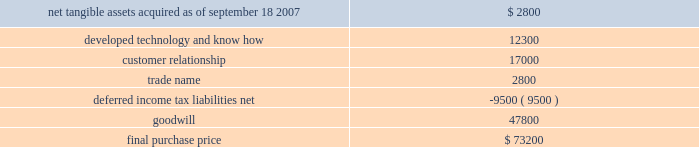Table of contents hologic , inc .
Notes to consolidated financial statements ( continued ) ( in thousands , except per share data ) the acquisition also provides for up to two annual earn-out payments not to exceed $ 15000 in the aggregate based on biolucent 2019s achievement of certain revenue targets .
The company considered the provision of eitf 95-8 , and concluded that this contingent consideration represents additional purchase price .
As a result , goodwill will be increased by the amount of the additional consideration , if any , as it is earned .
As of september 26 , 2009 , the company has not recorded any amounts for these potential earn-outs .
The allocation of the purchase price was based upon estimates of the fair value of assets acquired and liabilities assumed as of september 18 , 2007 .
The components and allocation of the purchase price consisted of the following approximate amounts: .
As part of the purchase price allocation , all intangible assets that were a part of the acquisition were identified and valued .
It was determined that only customer relationship , trade name and developed technology had separately identifiable values .
The fair value of these intangible assets was determined through the application of the income approach .
Customer relationship represented a large customer base that was expected to purchase the disposable mammopad product on a regular basis .
Trade name represented the biolucent product name that the company intended to continue to use .
Developed technology represented currently marketable purchased products that the company continues to sell as well as utilize to enhance and incorporate into the company 2019s existing products .
The deferred income tax liability relates to the tax effect of acquired identifiable intangible assets and fair value adjustments to acquired inventory , as such amounts are not deductible for tax purposes , partially offset by acquired net operating loss carryforwards of approximately $ 2400 .
Sale of gestiva on january 16 , 2008 , the company entered into a definitive agreement pursuant to which it agreed to sell full u.s .
And world-wide rights to gestiva to k-v pharmaceutical company upon approval of the pending gestiva new drug application ( the 201cgestiva nda 201d ) by the fda for a purchase price of $ 82000 .
The company received $ 9500 of the purchase price in fiscal 2008 , and the balance is due upon final approval of the gestiva nda by the fda on or before february 19 , 2010 and the production of a quantity of gestiva suitable to enable the commercial launch of the product .
Either party has the right to terminate the agreement if fda approval is not obtained by february 19 , 2010 .
The company agreed to continue its efforts to obtain fda approval of the nda for gestiva as part of this arrangement .
All costs incurred in these efforts will be reimbursed by k-v pharmaceutical and are being recorded as a credit against research and development expenses .
During fiscal 2009 and 2008 , these reimbursed costs were not material .
The company recorded the $ 9500 as a deferred gain within current liabilities in the consolidated balance sheet .
The company expects that the gain will be recognized upon the closing of the transaction following final fda approval of the gestiva nda or if the agreement is terminated .
The company cannot assure that it will be able to obtain the requisite fda approval , that the transaction will be completed or that it will receive the balance of the purchase price .
Moreover , if k-v pharmaceutical terminates the agreement as a result of a breach by the company of a material representation , warranty , covenant or agreement , the company will be required to return the funds previously received as well as expenses reimbursed by k-v .
Source : hologic inc , 10-k , november 24 , 2009 powered by morningstar ae document research 2120 the information contained herein may not be copied , adapted or distributed and is not warranted to be accurate , complete or timely .
The user assumes all risks for any damages or losses arising from any use of this information , except to the extent such damages or losses cannot be limited or excluded by applicable law .
Past financial performance is no guarantee of future results. .
What portion of the final purchase price is related to developed technology? 
Computations: (12300 / 73200)
Answer: 0.16803. 